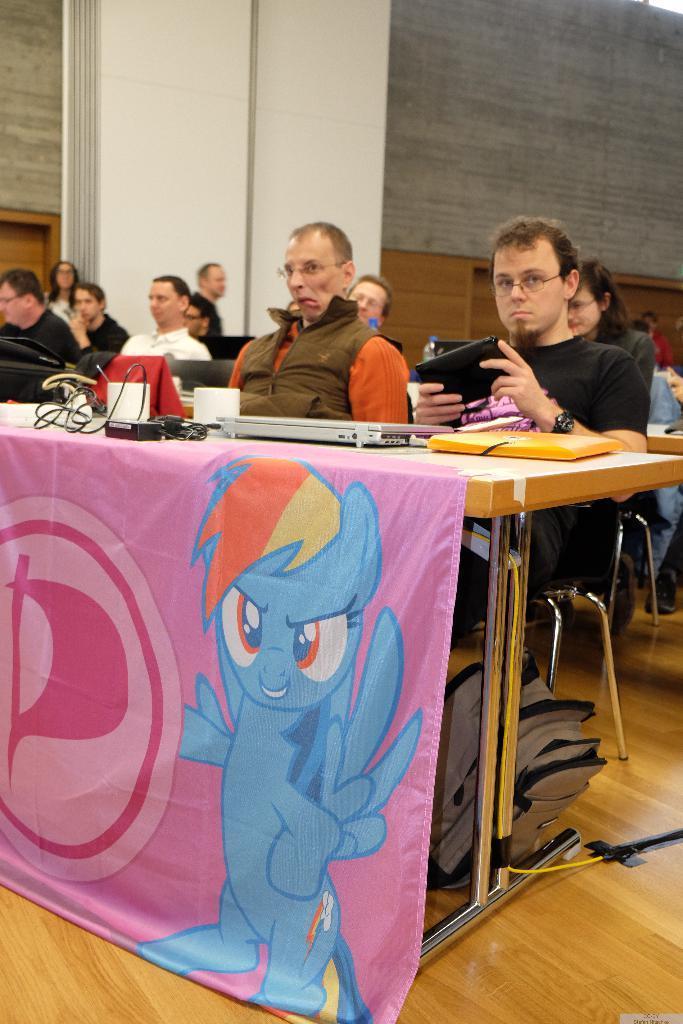In one or two sentences, can you explain what this image depicts? In this picture we can see some persons sitting on the chairs. This is bag. There is a table. On the table there are laptops and some cables. On the background there is a wall. And this is the floor. 